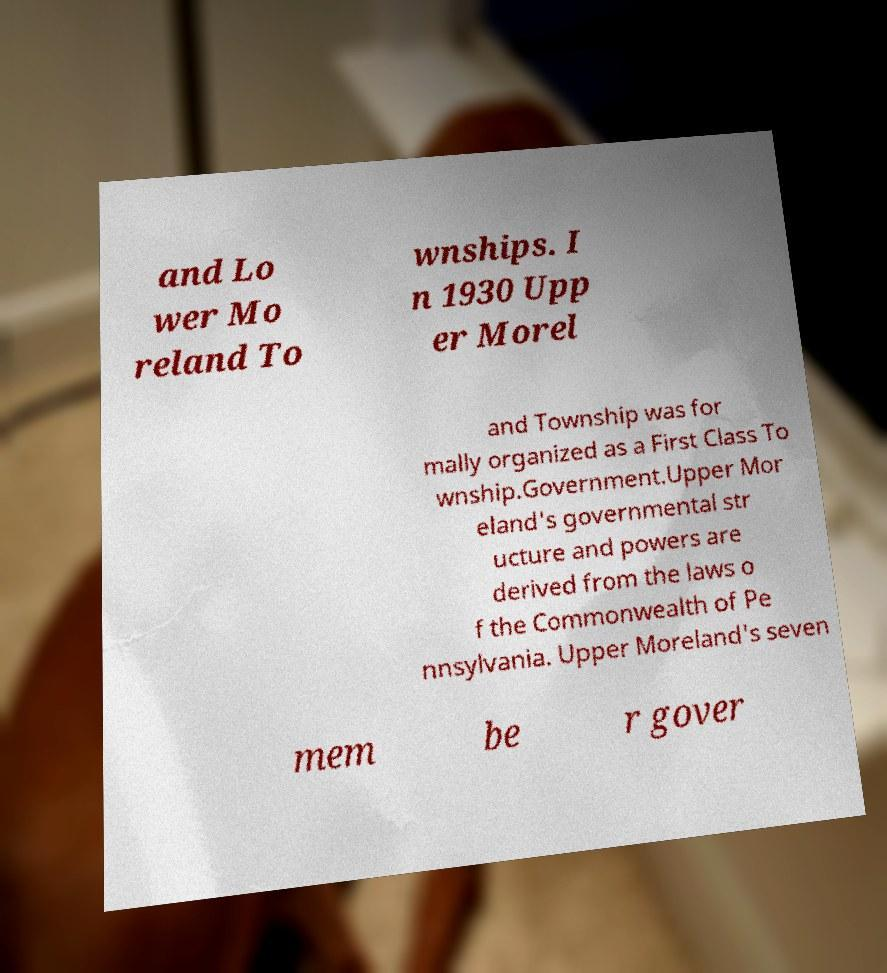Could you extract and type out the text from this image? and Lo wer Mo reland To wnships. I n 1930 Upp er Morel and Township was for mally organized as a First Class To wnship.Government.Upper Mor eland's governmental str ucture and powers are derived from the laws o f the Commonwealth of Pe nnsylvania. Upper Moreland's seven mem be r gover 